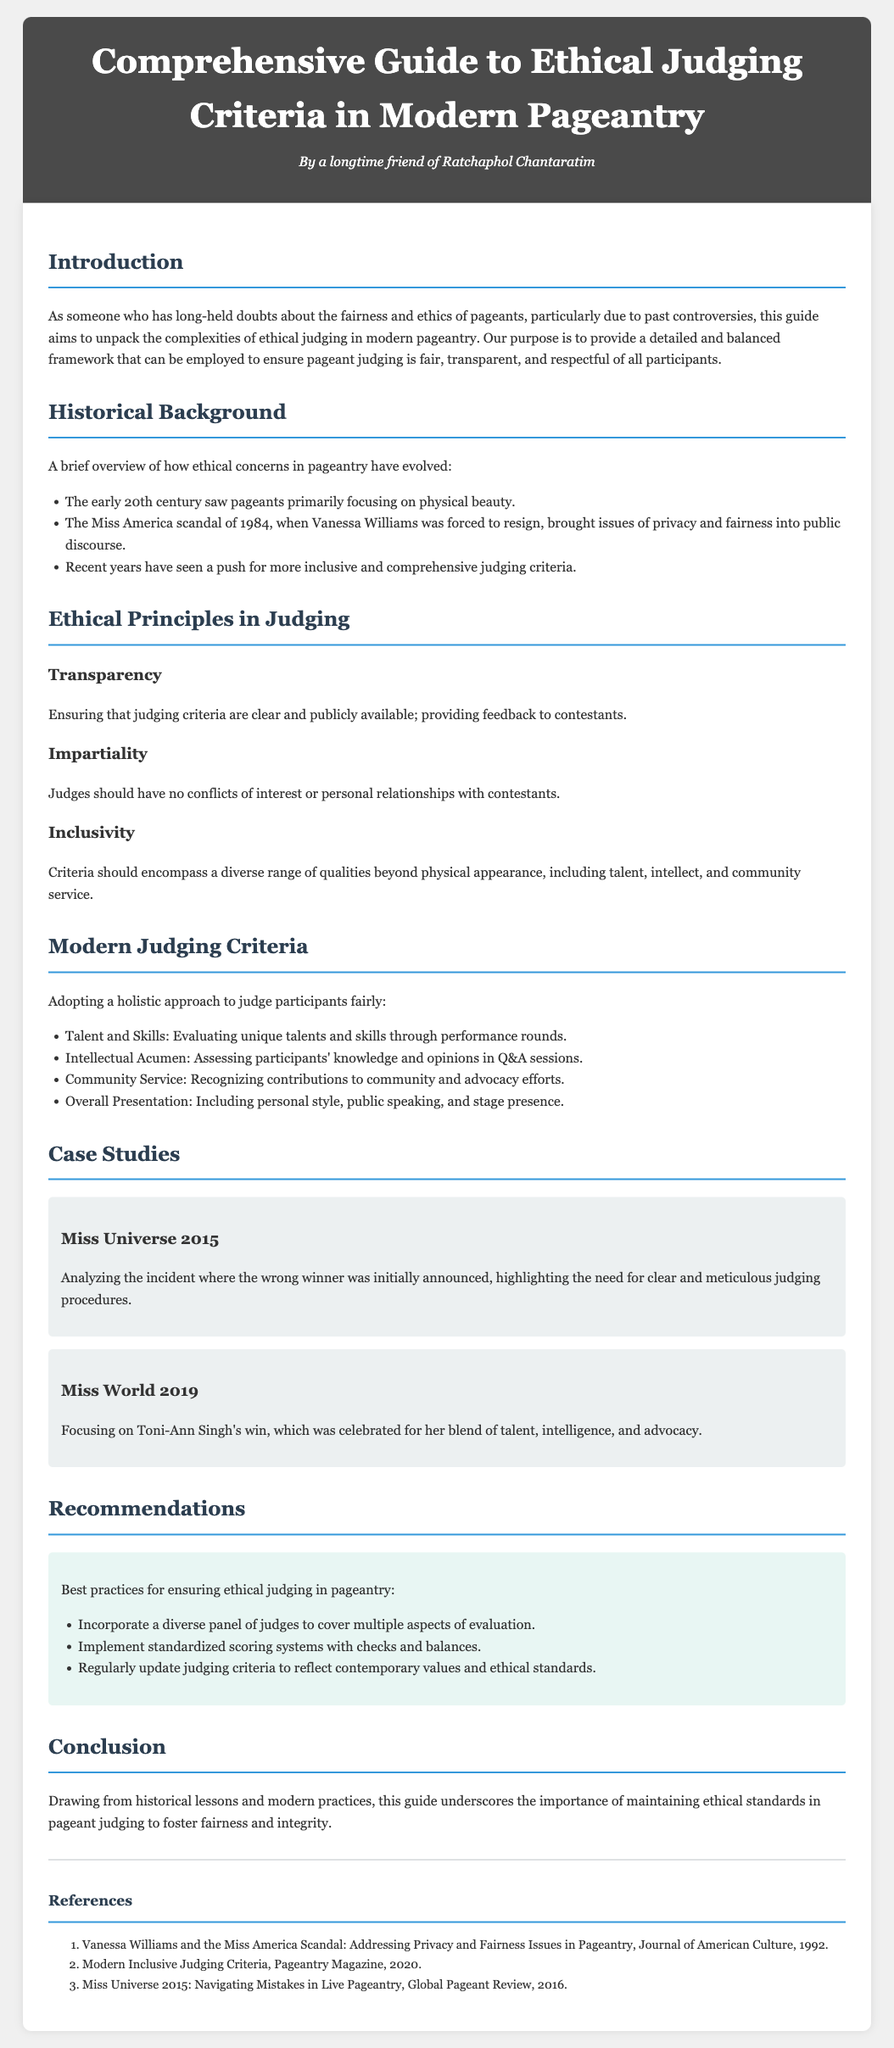What is the main focus of the guide? The guide aims to unpack the complexities of ethical judging in modern pageantry.
Answer: ethical judging What scandal is highlighted in the historical background? The document mentions the Miss America scandal of 1984 involving Vanessa Williams.
Answer: Miss America scandal of 1984 What are the three ethical principles in judging mentioned? The document lists transparency, impartiality, and inclusivity as ethical principles.
Answer: transparency, impartiality, inclusivity Which competition is referenced in the case study about a judging error? The document discusses an incident related to Miss Universe 2015, where the wrong winner was initially announced.
Answer: Miss Universe 2015 What should judging criteria encompass according to the modern judging criteria? The criteria should include talent, intellect, and community service beyond physical appearance.
Answer: talent, intellect, community service How many recommendations are provided for ethical judging practices? The document includes three best practices for ethical judging in pageantry.
Answer: three Who won Miss World in 2019? Toni-Ann Singh is noted for her win at Miss World 2019.
Answer: Toni-Ann Singh What is highlighted as a best practice for ethical judging? Incorporating a diverse panel of judges is listed as a best practice.
Answer: diverse panel of judges 